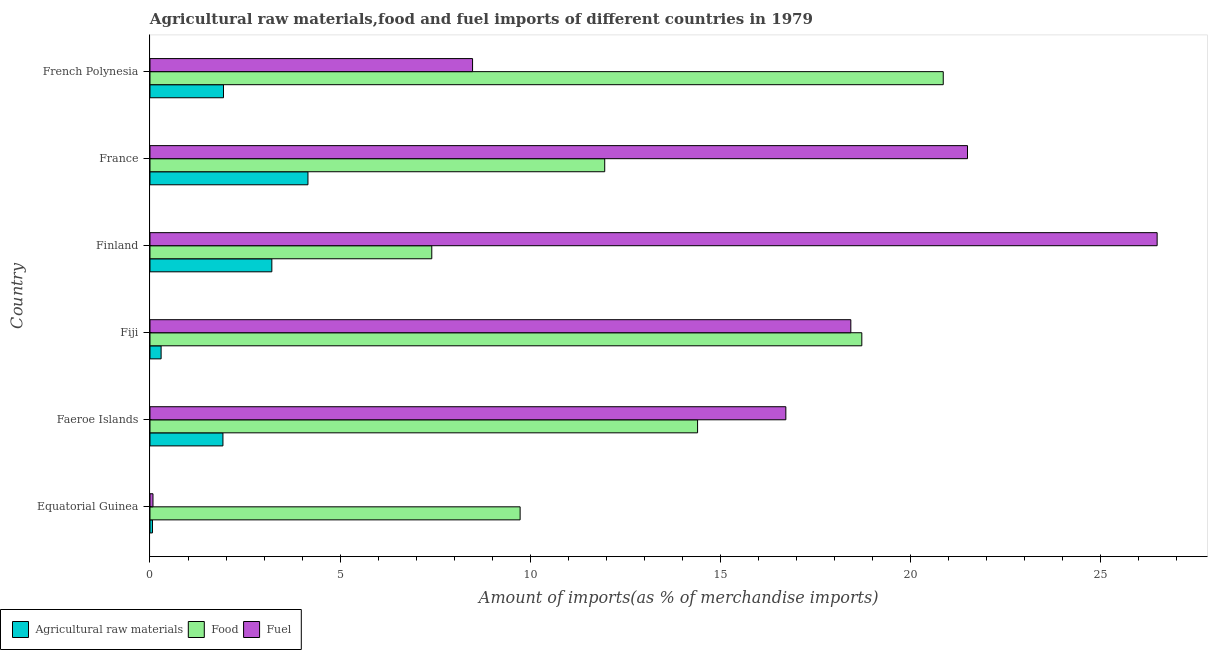How many different coloured bars are there?
Make the answer very short. 3. How many bars are there on the 2nd tick from the top?
Keep it short and to the point. 3. What is the label of the 2nd group of bars from the top?
Keep it short and to the point. France. What is the percentage of fuel imports in France?
Give a very brief answer. 21.51. Across all countries, what is the maximum percentage of food imports?
Make the answer very short. 20.87. Across all countries, what is the minimum percentage of fuel imports?
Offer a terse response. 0.08. In which country was the percentage of raw materials imports maximum?
Provide a short and direct response. France. In which country was the percentage of fuel imports minimum?
Your response must be concise. Equatorial Guinea. What is the total percentage of fuel imports in the graph?
Offer a very short reply. 91.73. What is the difference between the percentage of food imports in Equatorial Guinea and that in Finland?
Provide a short and direct response. 2.32. What is the difference between the percentage of fuel imports in Equatorial Guinea and the percentage of food imports in Finland?
Provide a succinct answer. -7.33. What is the average percentage of raw materials imports per country?
Your answer should be compact. 1.93. What is the difference between the percentage of raw materials imports and percentage of fuel imports in Fiji?
Your answer should be compact. -18.14. What is the ratio of the percentage of food imports in Fiji to that in Finland?
Make the answer very short. 2.53. Is the percentage of food imports in Finland less than that in France?
Provide a succinct answer. Yes. What is the difference between the highest and the second highest percentage of fuel imports?
Give a very brief answer. 4.99. What is the difference between the highest and the lowest percentage of fuel imports?
Offer a terse response. 26.42. In how many countries, is the percentage of fuel imports greater than the average percentage of fuel imports taken over all countries?
Provide a succinct answer. 4. What does the 2nd bar from the top in Faeroe Islands represents?
Offer a terse response. Food. What does the 2nd bar from the bottom in Equatorial Guinea represents?
Provide a short and direct response. Food. Is it the case that in every country, the sum of the percentage of raw materials imports and percentage of food imports is greater than the percentage of fuel imports?
Provide a succinct answer. No. Are all the bars in the graph horizontal?
Provide a short and direct response. Yes. What is the difference between two consecutive major ticks on the X-axis?
Offer a very short reply. 5. Are the values on the major ticks of X-axis written in scientific E-notation?
Provide a succinct answer. No. Does the graph contain any zero values?
Your answer should be very brief. No. What is the title of the graph?
Ensure brevity in your answer.  Agricultural raw materials,food and fuel imports of different countries in 1979. What is the label or title of the X-axis?
Make the answer very short. Amount of imports(as % of merchandise imports). What is the label or title of the Y-axis?
Provide a succinct answer. Country. What is the Amount of imports(as % of merchandise imports) in Agricultural raw materials in Equatorial Guinea?
Your answer should be very brief. 0.07. What is the Amount of imports(as % of merchandise imports) in Food in Equatorial Guinea?
Give a very brief answer. 9.74. What is the Amount of imports(as % of merchandise imports) in Fuel in Equatorial Guinea?
Offer a terse response. 0.08. What is the Amount of imports(as % of merchandise imports) in Agricultural raw materials in Faeroe Islands?
Give a very brief answer. 1.92. What is the Amount of imports(as % of merchandise imports) of Food in Faeroe Islands?
Offer a terse response. 14.41. What is the Amount of imports(as % of merchandise imports) in Fuel in Faeroe Islands?
Offer a terse response. 16.73. What is the Amount of imports(as % of merchandise imports) of Agricultural raw materials in Fiji?
Give a very brief answer. 0.29. What is the Amount of imports(as % of merchandise imports) of Food in Fiji?
Your response must be concise. 18.73. What is the Amount of imports(as % of merchandise imports) of Fuel in Fiji?
Make the answer very short. 18.44. What is the Amount of imports(as % of merchandise imports) in Agricultural raw materials in Finland?
Your answer should be compact. 3.21. What is the Amount of imports(as % of merchandise imports) in Food in Finland?
Give a very brief answer. 7.41. What is the Amount of imports(as % of merchandise imports) in Fuel in Finland?
Your answer should be compact. 26.49. What is the Amount of imports(as % of merchandise imports) of Agricultural raw materials in France?
Ensure brevity in your answer.  4.16. What is the Amount of imports(as % of merchandise imports) of Food in France?
Your answer should be compact. 11.96. What is the Amount of imports(as % of merchandise imports) of Fuel in France?
Your answer should be very brief. 21.51. What is the Amount of imports(as % of merchandise imports) in Agricultural raw materials in French Polynesia?
Your response must be concise. 1.93. What is the Amount of imports(as % of merchandise imports) in Food in French Polynesia?
Your response must be concise. 20.87. What is the Amount of imports(as % of merchandise imports) in Fuel in French Polynesia?
Give a very brief answer. 8.49. Across all countries, what is the maximum Amount of imports(as % of merchandise imports) in Agricultural raw materials?
Give a very brief answer. 4.16. Across all countries, what is the maximum Amount of imports(as % of merchandise imports) in Food?
Keep it short and to the point. 20.87. Across all countries, what is the maximum Amount of imports(as % of merchandise imports) in Fuel?
Ensure brevity in your answer.  26.49. Across all countries, what is the minimum Amount of imports(as % of merchandise imports) in Agricultural raw materials?
Your answer should be very brief. 0.07. Across all countries, what is the minimum Amount of imports(as % of merchandise imports) in Food?
Ensure brevity in your answer.  7.41. Across all countries, what is the minimum Amount of imports(as % of merchandise imports) of Fuel?
Offer a terse response. 0.08. What is the total Amount of imports(as % of merchandise imports) in Agricultural raw materials in the graph?
Ensure brevity in your answer.  11.57. What is the total Amount of imports(as % of merchandise imports) in Food in the graph?
Your answer should be compact. 83.11. What is the total Amount of imports(as % of merchandise imports) of Fuel in the graph?
Your answer should be compact. 91.73. What is the difference between the Amount of imports(as % of merchandise imports) of Agricultural raw materials in Equatorial Guinea and that in Faeroe Islands?
Offer a terse response. -1.85. What is the difference between the Amount of imports(as % of merchandise imports) of Food in Equatorial Guinea and that in Faeroe Islands?
Provide a succinct answer. -4.67. What is the difference between the Amount of imports(as % of merchandise imports) in Fuel in Equatorial Guinea and that in Faeroe Islands?
Keep it short and to the point. -16.65. What is the difference between the Amount of imports(as % of merchandise imports) in Agricultural raw materials in Equatorial Guinea and that in Fiji?
Ensure brevity in your answer.  -0.23. What is the difference between the Amount of imports(as % of merchandise imports) in Food in Equatorial Guinea and that in Fiji?
Offer a very short reply. -8.99. What is the difference between the Amount of imports(as % of merchandise imports) in Fuel in Equatorial Guinea and that in Fiji?
Provide a succinct answer. -18.36. What is the difference between the Amount of imports(as % of merchandise imports) in Agricultural raw materials in Equatorial Guinea and that in Finland?
Ensure brevity in your answer.  -3.14. What is the difference between the Amount of imports(as % of merchandise imports) in Food in Equatorial Guinea and that in Finland?
Offer a terse response. 2.32. What is the difference between the Amount of imports(as % of merchandise imports) in Fuel in Equatorial Guinea and that in Finland?
Offer a very short reply. -26.42. What is the difference between the Amount of imports(as % of merchandise imports) in Agricultural raw materials in Equatorial Guinea and that in France?
Your answer should be compact. -4.09. What is the difference between the Amount of imports(as % of merchandise imports) in Food in Equatorial Guinea and that in France?
Make the answer very short. -2.23. What is the difference between the Amount of imports(as % of merchandise imports) of Fuel in Equatorial Guinea and that in France?
Make the answer very short. -21.43. What is the difference between the Amount of imports(as % of merchandise imports) of Agricultural raw materials in Equatorial Guinea and that in French Polynesia?
Your answer should be very brief. -1.87. What is the difference between the Amount of imports(as % of merchandise imports) in Food in Equatorial Guinea and that in French Polynesia?
Give a very brief answer. -11.13. What is the difference between the Amount of imports(as % of merchandise imports) in Fuel in Equatorial Guinea and that in French Polynesia?
Your response must be concise. -8.41. What is the difference between the Amount of imports(as % of merchandise imports) in Agricultural raw materials in Faeroe Islands and that in Fiji?
Ensure brevity in your answer.  1.63. What is the difference between the Amount of imports(as % of merchandise imports) in Food in Faeroe Islands and that in Fiji?
Your answer should be very brief. -4.32. What is the difference between the Amount of imports(as % of merchandise imports) of Fuel in Faeroe Islands and that in Fiji?
Your response must be concise. -1.71. What is the difference between the Amount of imports(as % of merchandise imports) in Agricultural raw materials in Faeroe Islands and that in Finland?
Give a very brief answer. -1.29. What is the difference between the Amount of imports(as % of merchandise imports) of Food in Faeroe Islands and that in Finland?
Your response must be concise. 6.99. What is the difference between the Amount of imports(as % of merchandise imports) in Fuel in Faeroe Islands and that in Finland?
Your answer should be very brief. -9.77. What is the difference between the Amount of imports(as % of merchandise imports) of Agricultural raw materials in Faeroe Islands and that in France?
Ensure brevity in your answer.  -2.24. What is the difference between the Amount of imports(as % of merchandise imports) in Food in Faeroe Islands and that in France?
Give a very brief answer. 2.44. What is the difference between the Amount of imports(as % of merchandise imports) of Fuel in Faeroe Islands and that in France?
Your answer should be compact. -4.78. What is the difference between the Amount of imports(as % of merchandise imports) of Agricultural raw materials in Faeroe Islands and that in French Polynesia?
Your response must be concise. -0.01. What is the difference between the Amount of imports(as % of merchandise imports) in Food in Faeroe Islands and that in French Polynesia?
Your answer should be compact. -6.46. What is the difference between the Amount of imports(as % of merchandise imports) of Fuel in Faeroe Islands and that in French Polynesia?
Offer a very short reply. 8.24. What is the difference between the Amount of imports(as % of merchandise imports) of Agricultural raw materials in Fiji and that in Finland?
Offer a terse response. -2.91. What is the difference between the Amount of imports(as % of merchandise imports) in Food in Fiji and that in Finland?
Provide a short and direct response. 11.31. What is the difference between the Amount of imports(as % of merchandise imports) of Fuel in Fiji and that in Finland?
Your response must be concise. -8.06. What is the difference between the Amount of imports(as % of merchandise imports) in Agricultural raw materials in Fiji and that in France?
Provide a short and direct response. -3.86. What is the difference between the Amount of imports(as % of merchandise imports) in Food in Fiji and that in France?
Your answer should be very brief. 6.76. What is the difference between the Amount of imports(as % of merchandise imports) in Fuel in Fiji and that in France?
Give a very brief answer. -3.07. What is the difference between the Amount of imports(as % of merchandise imports) of Agricultural raw materials in Fiji and that in French Polynesia?
Your response must be concise. -1.64. What is the difference between the Amount of imports(as % of merchandise imports) in Food in Fiji and that in French Polynesia?
Keep it short and to the point. -2.14. What is the difference between the Amount of imports(as % of merchandise imports) of Fuel in Fiji and that in French Polynesia?
Give a very brief answer. 9.95. What is the difference between the Amount of imports(as % of merchandise imports) of Agricultural raw materials in Finland and that in France?
Offer a very short reply. -0.95. What is the difference between the Amount of imports(as % of merchandise imports) in Food in Finland and that in France?
Your answer should be compact. -4.55. What is the difference between the Amount of imports(as % of merchandise imports) of Fuel in Finland and that in France?
Keep it short and to the point. 4.99. What is the difference between the Amount of imports(as % of merchandise imports) in Agricultural raw materials in Finland and that in French Polynesia?
Your answer should be very brief. 1.27. What is the difference between the Amount of imports(as % of merchandise imports) of Food in Finland and that in French Polynesia?
Your answer should be very brief. -13.45. What is the difference between the Amount of imports(as % of merchandise imports) in Fuel in Finland and that in French Polynesia?
Give a very brief answer. 18.01. What is the difference between the Amount of imports(as % of merchandise imports) of Agricultural raw materials in France and that in French Polynesia?
Make the answer very short. 2.22. What is the difference between the Amount of imports(as % of merchandise imports) of Food in France and that in French Polynesia?
Ensure brevity in your answer.  -8.91. What is the difference between the Amount of imports(as % of merchandise imports) in Fuel in France and that in French Polynesia?
Provide a succinct answer. 13.02. What is the difference between the Amount of imports(as % of merchandise imports) of Agricultural raw materials in Equatorial Guinea and the Amount of imports(as % of merchandise imports) of Food in Faeroe Islands?
Give a very brief answer. -14.34. What is the difference between the Amount of imports(as % of merchandise imports) of Agricultural raw materials in Equatorial Guinea and the Amount of imports(as % of merchandise imports) of Fuel in Faeroe Islands?
Your response must be concise. -16.66. What is the difference between the Amount of imports(as % of merchandise imports) in Food in Equatorial Guinea and the Amount of imports(as % of merchandise imports) in Fuel in Faeroe Islands?
Provide a succinct answer. -6.99. What is the difference between the Amount of imports(as % of merchandise imports) in Agricultural raw materials in Equatorial Guinea and the Amount of imports(as % of merchandise imports) in Food in Fiji?
Ensure brevity in your answer.  -18.66. What is the difference between the Amount of imports(as % of merchandise imports) of Agricultural raw materials in Equatorial Guinea and the Amount of imports(as % of merchandise imports) of Fuel in Fiji?
Make the answer very short. -18.37. What is the difference between the Amount of imports(as % of merchandise imports) in Food in Equatorial Guinea and the Amount of imports(as % of merchandise imports) in Fuel in Fiji?
Keep it short and to the point. -8.7. What is the difference between the Amount of imports(as % of merchandise imports) of Agricultural raw materials in Equatorial Guinea and the Amount of imports(as % of merchandise imports) of Food in Finland?
Offer a very short reply. -7.35. What is the difference between the Amount of imports(as % of merchandise imports) in Agricultural raw materials in Equatorial Guinea and the Amount of imports(as % of merchandise imports) in Fuel in Finland?
Keep it short and to the point. -26.43. What is the difference between the Amount of imports(as % of merchandise imports) in Food in Equatorial Guinea and the Amount of imports(as % of merchandise imports) in Fuel in Finland?
Provide a succinct answer. -16.76. What is the difference between the Amount of imports(as % of merchandise imports) in Agricultural raw materials in Equatorial Guinea and the Amount of imports(as % of merchandise imports) in Food in France?
Ensure brevity in your answer.  -11.9. What is the difference between the Amount of imports(as % of merchandise imports) of Agricultural raw materials in Equatorial Guinea and the Amount of imports(as % of merchandise imports) of Fuel in France?
Your answer should be very brief. -21.44. What is the difference between the Amount of imports(as % of merchandise imports) of Food in Equatorial Guinea and the Amount of imports(as % of merchandise imports) of Fuel in France?
Make the answer very short. -11.77. What is the difference between the Amount of imports(as % of merchandise imports) in Agricultural raw materials in Equatorial Guinea and the Amount of imports(as % of merchandise imports) in Food in French Polynesia?
Give a very brief answer. -20.8. What is the difference between the Amount of imports(as % of merchandise imports) of Agricultural raw materials in Equatorial Guinea and the Amount of imports(as % of merchandise imports) of Fuel in French Polynesia?
Provide a short and direct response. -8.42. What is the difference between the Amount of imports(as % of merchandise imports) in Food in Equatorial Guinea and the Amount of imports(as % of merchandise imports) in Fuel in French Polynesia?
Your answer should be compact. 1.25. What is the difference between the Amount of imports(as % of merchandise imports) of Agricultural raw materials in Faeroe Islands and the Amount of imports(as % of merchandise imports) of Food in Fiji?
Provide a short and direct response. -16.81. What is the difference between the Amount of imports(as % of merchandise imports) of Agricultural raw materials in Faeroe Islands and the Amount of imports(as % of merchandise imports) of Fuel in Fiji?
Provide a short and direct response. -16.52. What is the difference between the Amount of imports(as % of merchandise imports) of Food in Faeroe Islands and the Amount of imports(as % of merchandise imports) of Fuel in Fiji?
Keep it short and to the point. -4.03. What is the difference between the Amount of imports(as % of merchandise imports) of Agricultural raw materials in Faeroe Islands and the Amount of imports(as % of merchandise imports) of Food in Finland?
Offer a very short reply. -5.49. What is the difference between the Amount of imports(as % of merchandise imports) of Agricultural raw materials in Faeroe Islands and the Amount of imports(as % of merchandise imports) of Fuel in Finland?
Provide a short and direct response. -24.57. What is the difference between the Amount of imports(as % of merchandise imports) of Food in Faeroe Islands and the Amount of imports(as % of merchandise imports) of Fuel in Finland?
Make the answer very short. -12.09. What is the difference between the Amount of imports(as % of merchandise imports) of Agricultural raw materials in Faeroe Islands and the Amount of imports(as % of merchandise imports) of Food in France?
Provide a short and direct response. -10.04. What is the difference between the Amount of imports(as % of merchandise imports) in Agricultural raw materials in Faeroe Islands and the Amount of imports(as % of merchandise imports) in Fuel in France?
Keep it short and to the point. -19.59. What is the difference between the Amount of imports(as % of merchandise imports) in Food in Faeroe Islands and the Amount of imports(as % of merchandise imports) in Fuel in France?
Keep it short and to the point. -7.1. What is the difference between the Amount of imports(as % of merchandise imports) of Agricultural raw materials in Faeroe Islands and the Amount of imports(as % of merchandise imports) of Food in French Polynesia?
Make the answer very short. -18.95. What is the difference between the Amount of imports(as % of merchandise imports) of Agricultural raw materials in Faeroe Islands and the Amount of imports(as % of merchandise imports) of Fuel in French Polynesia?
Offer a very short reply. -6.57. What is the difference between the Amount of imports(as % of merchandise imports) in Food in Faeroe Islands and the Amount of imports(as % of merchandise imports) in Fuel in French Polynesia?
Make the answer very short. 5.92. What is the difference between the Amount of imports(as % of merchandise imports) of Agricultural raw materials in Fiji and the Amount of imports(as % of merchandise imports) of Food in Finland?
Your response must be concise. -7.12. What is the difference between the Amount of imports(as % of merchandise imports) in Agricultural raw materials in Fiji and the Amount of imports(as % of merchandise imports) in Fuel in Finland?
Ensure brevity in your answer.  -26.2. What is the difference between the Amount of imports(as % of merchandise imports) of Food in Fiji and the Amount of imports(as % of merchandise imports) of Fuel in Finland?
Keep it short and to the point. -7.77. What is the difference between the Amount of imports(as % of merchandise imports) in Agricultural raw materials in Fiji and the Amount of imports(as % of merchandise imports) in Food in France?
Provide a short and direct response. -11.67. What is the difference between the Amount of imports(as % of merchandise imports) in Agricultural raw materials in Fiji and the Amount of imports(as % of merchandise imports) in Fuel in France?
Keep it short and to the point. -21.21. What is the difference between the Amount of imports(as % of merchandise imports) of Food in Fiji and the Amount of imports(as % of merchandise imports) of Fuel in France?
Ensure brevity in your answer.  -2.78. What is the difference between the Amount of imports(as % of merchandise imports) in Agricultural raw materials in Fiji and the Amount of imports(as % of merchandise imports) in Food in French Polynesia?
Provide a succinct answer. -20.58. What is the difference between the Amount of imports(as % of merchandise imports) in Agricultural raw materials in Fiji and the Amount of imports(as % of merchandise imports) in Fuel in French Polynesia?
Your answer should be very brief. -8.19. What is the difference between the Amount of imports(as % of merchandise imports) in Food in Fiji and the Amount of imports(as % of merchandise imports) in Fuel in French Polynesia?
Your answer should be very brief. 10.24. What is the difference between the Amount of imports(as % of merchandise imports) of Agricultural raw materials in Finland and the Amount of imports(as % of merchandise imports) of Food in France?
Keep it short and to the point. -8.76. What is the difference between the Amount of imports(as % of merchandise imports) of Agricultural raw materials in Finland and the Amount of imports(as % of merchandise imports) of Fuel in France?
Offer a very short reply. -18.3. What is the difference between the Amount of imports(as % of merchandise imports) of Food in Finland and the Amount of imports(as % of merchandise imports) of Fuel in France?
Make the answer very short. -14.09. What is the difference between the Amount of imports(as % of merchandise imports) in Agricultural raw materials in Finland and the Amount of imports(as % of merchandise imports) in Food in French Polynesia?
Offer a terse response. -17.66. What is the difference between the Amount of imports(as % of merchandise imports) of Agricultural raw materials in Finland and the Amount of imports(as % of merchandise imports) of Fuel in French Polynesia?
Your response must be concise. -5.28. What is the difference between the Amount of imports(as % of merchandise imports) in Food in Finland and the Amount of imports(as % of merchandise imports) in Fuel in French Polynesia?
Offer a very short reply. -1.07. What is the difference between the Amount of imports(as % of merchandise imports) of Agricultural raw materials in France and the Amount of imports(as % of merchandise imports) of Food in French Polynesia?
Make the answer very short. -16.71. What is the difference between the Amount of imports(as % of merchandise imports) of Agricultural raw materials in France and the Amount of imports(as % of merchandise imports) of Fuel in French Polynesia?
Your answer should be compact. -4.33. What is the difference between the Amount of imports(as % of merchandise imports) of Food in France and the Amount of imports(as % of merchandise imports) of Fuel in French Polynesia?
Your answer should be very brief. 3.48. What is the average Amount of imports(as % of merchandise imports) in Agricultural raw materials per country?
Provide a succinct answer. 1.93. What is the average Amount of imports(as % of merchandise imports) of Food per country?
Keep it short and to the point. 13.85. What is the average Amount of imports(as % of merchandise imports) in Fuel per country?
Offer a terse response. 15.29. What is the difference between the Amount of imports(as % of merchandise imports) in Agricultural raw materials and Amount of imports(as % of merchandise imports) in Food in Equatorial Guinea?
Your answer should be very brief. -9.67. What is the difference between the Amount of imports(as % of merchandise imports) in Agricultural raw materials and Amount of imports(as % of merchandise imports) in Fuel in Equatorial Guinea?
Provide a succinct answer. -0.01. What is the difference between the Amount of imports(as % of merchandise imports) in Food and Amount of imports(as % of merchandise imports) in Fuel in Equatorial Guinea?
Offer a very short reply. 9.66. What is the difference between the Amount of imports(as % of merchandise imports) in Agricultural raw materials and Amount of imports(as % of merchandise imports) in Food in Faeroe Islands?
Offer a very short reply. -12.49. What is the difference between the Amount of imports(as % of merchandise imports) of Agricultural raw materials and Amount of imports(as % of merchandise imports) of Fuel in Faeroe Islands?
Your response must be concise. -14.81. What is the difference between the Amount of imports(as % of merchandise imports) in Food and Amount of imports(as % of merchandise imports) in Fuel in Faeroe Islands?
Offer a very short reply. -2.32. What is the difference between the Amount of imports(as % of merchandise imports) in Agricultural raw materials and Amount of imports(as % of merchandise imports) in Food in Fiji?
Provide a succinct answer. -18.43. What is the difference between the Amount of imports(as % of merchandise imports) of Agricultural raw materials and Amount of imports(as % of merchandise imports) of Fuel in Fiji?
Make the answer very short. -18.14. What is the difference between the Amount of imports(as % of merchandise imports) of Food and Amount of imports(as % of merchandise imports) of Fuel in Fiji?
Your answer should be compact. 0.29. What is the difference between the Amount of imports(as % of merchandise imports) in Agricultural raw materials and Amount of imports(as % of merchandise imports) in Food in Finland?
Provide a succinct answer. -4.21. What is the difference between the Amount of imports(as % of merchandise imports) in Agricultural raw materials and Amount of imports(as % of merchandise imports) in Fuel in Finland?
Your answer should be very brief. -23.29. What is the difference between the Amount of imports(as % of merchandise imports) of Food and Amount of imports(as % of merchandise imports) of Fuel in Finland?
Offer a very short reply. -19.08. What is the difference between the Amount of imports(as % of merchandise imports) of Agricultural raw materials and Amount of imports(as % of merchandise imports) of Food in France?
Give a very brief answer. -7.81. What is the difference between the Amount of imports(as % of merchandise imports) in Agricultural raw materials and Amount of imports(as % of merchandise imports) in Fuel in France?
Ensure brevity in your answer.  -17.35. What is the difference between the Amount of imports(as % of merchandise imports) of Food and Amount of imports(as % of merchandise imports) of Fuel in France?
Offer a terse response. -9.54. What is the difference between the Amount of imports(as % of merchandise imports) of Agricultural raw materials and Amount of imports(as % of merchandise imports) of Food in French Polynesia?
Give a very brief answer. -18.93. What is the difference between the Amount of imports(as % of merchandise imports) in Agricultural raw materials and Amount of imports(as % of merchandise imports) in Fuel in French Polynesia?
Provide a succinct answer. -6.55. What is the difference between the Amount of imports(as % of merchandise imports) of Food and Amount of imports(as % of merchandise imports) of Fuel in French Polynesia?
Your response must be concise. 12.38. What is the ratio of the Amount of imports(as % of merchandise imports) of Agricultural raw materials in Equatorial Guinea to that in Faeroe Islands?
Your response must be concise. 0.03. What is the ratio of the Amount of imports(as % of merchandise imports) of Food in Equatorial Guinea to that in Faeroe Islands?
Ensure brevity in your answer.  0.68. What is the ratio of the Amount of imports(as % of merchandise imports) in Fuel in Equatorial Guinea to that in Faeroe Islands?
Your answer should be very brief. 0. What is the ratio of the Amount of imports(as % of merchandise imports) of Agricultural raw materials in Equatorial Guinea to that in Fiji?
Offer a very short reply. 0.22. What is the ratio of the Amount of imports(as % of merchandise imports) in Food in Equatorial Guinea to that in Fiji?
Provide a short and direct response. 0.52. What is the ratio of the Amount of imports(as % of merchandise imports) of Fuel in Equatorial Guinea to that in Fiji?
Your response must be concise. 0. What is the ratio of the Amount of imports(as % of merchandise imports) of Agricultural raw materials in Equatorial Guinea to that in Finland?
Your response must be concise. 0.02. What is the ratio of the Amount of imports(as % of merchandise imports) of Food in Equatorial Guinea to that in Finland?
Keep it short and to the point. 1.31. What is the ratio of the Amount of imports(as % of merchandise imports) of Fuel in Equatorial Guinea to that in Finland?
Your answer should be very brief. 0. What is the ratio of the Amount of imports(as % of merchandise imports) in Agricultural raw materials in Equatorial Guinea to that in France?
Keep it short and to the point. 0.02. What is the ratio of the Amount of imports(as % of merchandise imports) of Food in Equatorial Guinea to that in France?
Your answer should be very brief. 0.81. What is the ratio of the Amount of imports(as % of merchandise imports) of Fuel in Equatorial Guinea to that in France?
Make the answer very short. 0. What is the ratio of the Amount of imports(as % of merchandise imports) of Agricultural raw materials in Equatorial Guinea to that in French Polynesia?
Give a very brief answer. 0.03. What is the ratio of the Amount of imports(as % of merchandise imports) in Food in Equatorial Guinea to that in French Polynesia?
Provide a short and direct response. 0.47. What is the ratio of the Amount of imports(as % of merchandise imports) of Fuel in Equatorial Guinea to that in French Polynesia?
Offer a very short reply. 0.01. What is the ratio of the Amount of imports(as % of merchandise imports) of Agricultural raw materials in Faeroe Islands to that in Fiji?
Ensure brevity in your answer.  6.56. What is the ratio of the Amount of imports(as % of merchandise imports) of Food in Faeroe Islands to that in Fiji?
Provide a succinct answer. 0.77. What is the ratio of the Amount of imports(as % of merchandise imports) in Fuel in Faeroe Islands to that in Fiji?
Keep it short and to the point. 0.91. What is the ratio of the Amount of imports(as % of merchandise imports) in Agricultural raw materials in Faeroe Islands to that in Finland?
Your answer should be very brief. 0.6. What is the ratio of the Amount of imports(as % of merchandise imports) of Food in Faeroe Islands to that in Finland?
Your response must be concise. 1.94. What is the ratio of the Amount of imports(as % of merchandise imports) of Fuel in Faeroe Islands to that in Finland?
Your answer should be compact. 0.63. What is the ratio of the Amount of imports(as % of merchandise imports) of Agricultural raw materials in Faeroe Islands to that in France?
Your response must be concise. 0.46. What is the ratio of the Amount of imports(as % of merchandise imports) in Food in Faeroe Islands to that in France?
Your answer should be very brief. 1.2. What is the ratio of the Amount of imports(as % of merchandise imports) in Fuel in Faeroe Islands to that in France?
Your response must be concise. 0.78. What is the ratio of the Amount of imports(as % of merchandise imports) in Food in Faeroe Islands to that in French Polynesia?
Your answer should be compact. 0.69. What is the ratio of the Amount of imports(as % of merchandise imports) in Fuel in Faeroe Islands to that in French Polynesia?
Your answer should be compact. 1.97. What is the ratio of the Amount of imports(as % of merchandise imports) of Agricultural raw materials in Fiji to that in Finland?
Offer a very short reply. 0.09. What is the ratio of the Amount of imports(as % of merchandise imports) in Food in Fiji to that in Finland?
Offer a very short reply. 2.53. What is the ratio of the Amount of imports(as % of merchandise imports) of Fuel in Fiji to that in Finland?
Your response must be concise. 0.7. What is the ratio of the Amount of imports(as % of merchandise imports) of Agricultural raw materials in Fiji to that in France?
Your answer should be compact. 0.07. What is the ratio of the Amount of imports(as % of merchandise imports) of Food in Fiji to that in France?
Provide a short and direct response. 1.57. What is the ratio of the Amount of imports(as % of merchandise imports) of Fuel in Fiji to that in France?
Give a very brief answer. 0.86. What is the ratio of the Amount of imports(as % of merchandise imports) in Agricultural raw materials in Fiji to that in French Polynesia?
Make the answer very short. 0.15. What is the ratio of the Amount of imports(as % of merchandise imports) in Food in Fiji to that in French Polynesia?
Provide a succinct answer. 0.9. What is the ratio of the Amount of imports(as % of merchandise imports) in Fuel in Fiji to that in French Polynesia?
Provide a succinct answer. 2.17. What is the ratio of the Amount of imports(as % of merchandise imports) of Agricultural raw materials in Finland to that in France?
Keep it short and to the point. 0.77. What is the ratio of the Amount of imports(as % of merchandise imports) of Food in Finland to that in France?
Ensure brevity in your answer.  0.62. What is the ratio of the Amount of imports(as % of merchandise imports) of Fuel in Finland to that in France?
Make the answer very short. 1.23. What is the ratio of the Amount of imports(as % of merchandise imports) of Agricultural raw materials in Finland to that in French Polynesia?
Your answer should be very brief. 1.66. What is the ratio of the Amount of imports(as % of merchandise imports) in Food in Finland to that in French Polynesia?
Give a very brief answer. 0.36. What is the ratio of the Amount of imports(as % of merchandise imports) in Fuel in Finland to that in French Polynesia?
Keep it short and to the point. 3.12. What is the ratio of the Amount of imports(as % of merchandise imports) of Agricultural raw materials in France to that in French Polynesia?
Your response must be concise. 2.15. What is the ratio of the Amount of imports(as % of merchandise imports) of Food in France to that in French Polynesia?
Give a very brief answer. 0.57. What is the ratio of the Amount of imports(as % of merchandise imports) in Fuel in France to that in French Polynesia?
Keep it short and to the point. 2.53. What is the difference between the highest and the second highest Amount of imports(as % of merchandise imports) in Agricultural raw materials?
Offer a terse response. 0.95. What is the difference between the highest and the second highest Amount of imports(as % of merchandise imports) in Food?
Offer a very short reply. 2.14. What is the difference between the highest and the second highest Amount of imports(as % of merchandise imports) in Fuel?
Provide a short and direct response. 4.99. What is the difference between the highest and the lowest Amount of imports(as % of merchandise imports) of Agricultural raw materials?
Offer a terse response. 4.09. What is the difference between the highest and the lowest Amount of imports(as % of merchandise imports) in Food?
Offer a very short reply. 13.45. What is the difference between the highest and the lowest Amount of imports(as % of merchandise imports) of Fuel?
Your response must be concise. 26.42. 